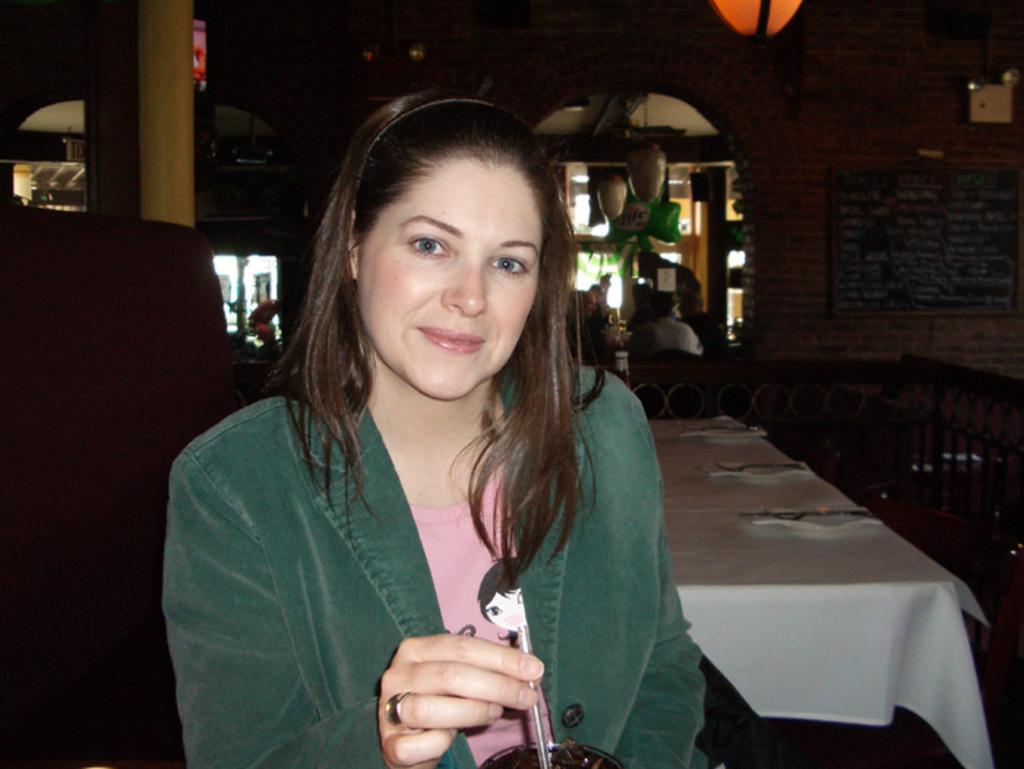Who is the main subject in the image? There is a woman in the image. What is the woman wearing? The woman is wearing a green jacket. What is the woman holding in her hand? The woman is holding an object in her hand. What type of furniture can be seen in the image? There is a table and chairs in the image. What type of muscle is visible on the woman's arm in the image? There is no muscle visible on the woman's arm in the image. What scientific principle is being demonstrated in the image? There is no scientific principle being demonstrated in the image. 